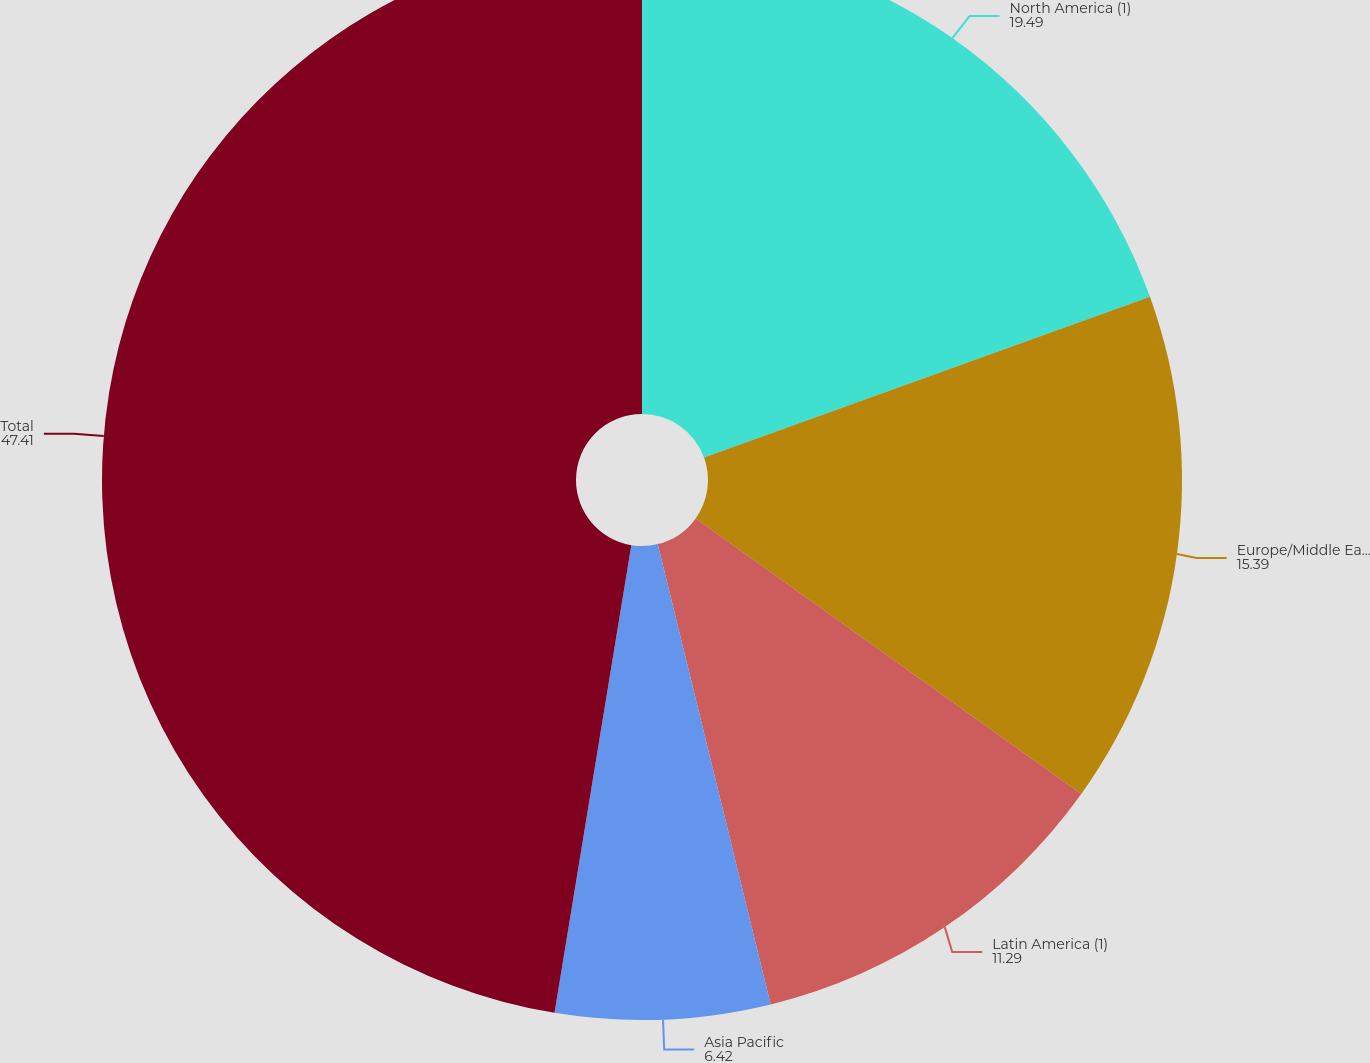Convert chart. <chart><loc_0><loc_0><loc_500><loc_500><pie_chart><fcel>North America (1)<fcel>Europe/Middle East/Africa<fcel>Latin America (1)<fcel>Asia Pacific<fcel>Total<nl><fcel>19.49%<fcel>15.39%<fcel>11.29%<fcel>6.42%<fcel>47.41%<nl></chart> 